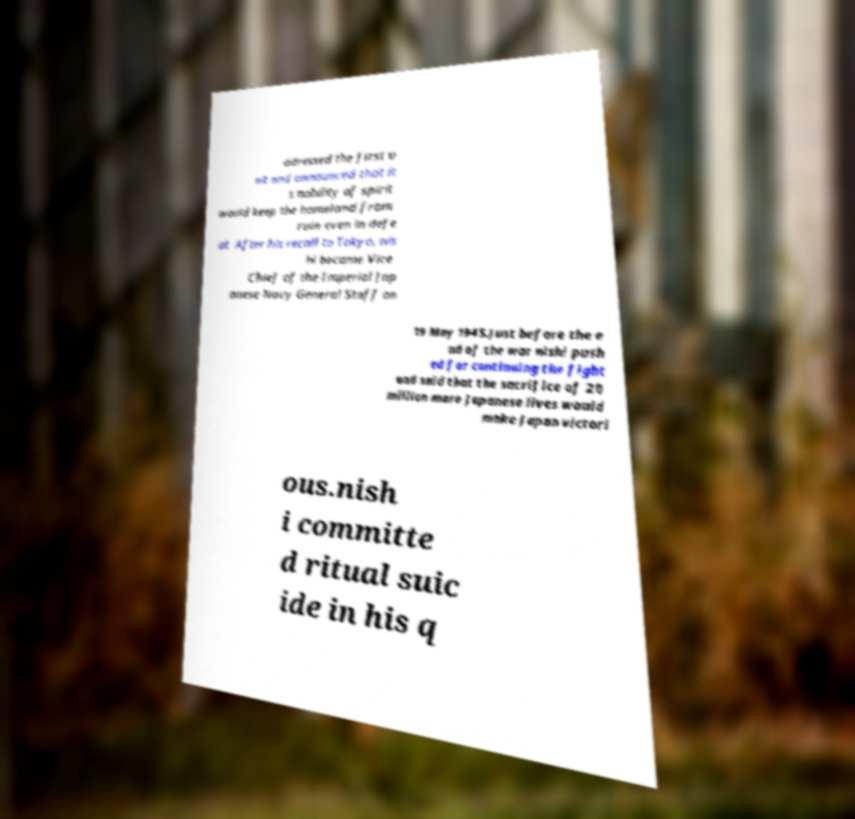Could you extract and type out the text from this image? ddressed the first u nit and announced that it s nobility of spirit would keep the homeland from ruin even in defe at. After his recall to Tokyo, nis hi became Vice Chief of the Imperial Jap anese Navy General Staff on 19 May 1945.Just before the e nd of the war nishi push ed for continuing the fight and said that the sacrifice of 20 million more Japanese lives would make Japan victori ous.nish i committe d ritual suic ide in his q 